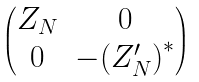Convert formula to latex. <formula><loc_0><loc_0><loc_500><loc_500>\begin{pmatrix} Z _ { N } & 0 \\ 0 & - { ( Z ^ { \prime } _ { N } ) } ^ { * } \end{pmatrix}</formula> 